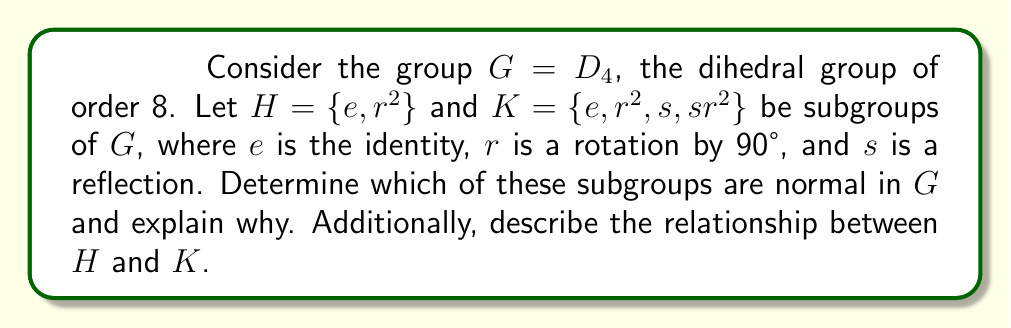Could you help me with this problem? To determine which subgroups are normal and understand their relationship, we'll follow these steps:

1) Recall that a subgroup $N$ of $G$ is normal if $gNg^{-1} = N$ for all $g \in G$.

2) For $H = \{e, r^2\}$:
   Let's conjugate $H$ by elements of $G$:
   - $rHr^{-1} = \{rer^{-1}, rr^2r^{-1}\} = \{e, r^2\} = H$
   - $sHs^{-1} = \{ses^{-1}, sr^2s^{-1}\} = \{e, r^2\} = H$
   
   Since $r$ and $s$ generate $D_4$, and conjugation by both preserves $H$, we can conclude that $H$ is normal in $G$.

3) For $K = \{e, r^2, s, sr^2\}$:
   Let's conjugate $K$ by $r$:
   $rKr^{-1} = \{rer^{-1}, rr^2r^{-1}, rsr^{-1}, rsr^2r^{-1}\} = \{e, r^2, rs, rsr^2\}$
   
   Note that $rs \neq s$ and $rsr^2 \neq sr^2$, so $rKr^{-1} \neq K$.
   Therefore, $K$ is not normal in $G$.

4) Relationship between $H$ and $K$:
   - $H$ is a subgroup of $K$, as $H \subset K$.
   - $|H| = 2$ and $|K| = 4$, so $[K:H] = 2$.
   - $K$ is normal in $G$ (as shown in step 3).
   - $H$ is normal in $K$ because $K/H$ has order 2, and any subgroup of index 2 is normal.

5) This scenario illustrates an important relationship:
   - A normal subgroup of a normal subgroup is not necessarily normal in the whole group.
   - Here, $H$ is normal in $K$, and $K$ is normal in $G$, but $H$ is also normal in $G$.
   - This is because normality is not generally a transitive relation.

6) However, we can observe that in this case:
   - $H$ is the only non-trivial proper normal subgroup of $G$.
   - $K$ is a maximal subgroup of $G$ (there's no subgroup strictly between $K$ and $G$).
Answer: $H = \{e, r^2\}$ is normal in $G$, while $K = \{e, r^2, s, sr^2\}$ is not normal in $G$. $H$ is a subgroup of $K$, and $H$ is normal in both $K$ and $G$, demonstrating that normality is not transitive. $K$ is a maximal subgroup of $G$, and $H$ is the only non-trivial proper normal subgroup of $G$. 